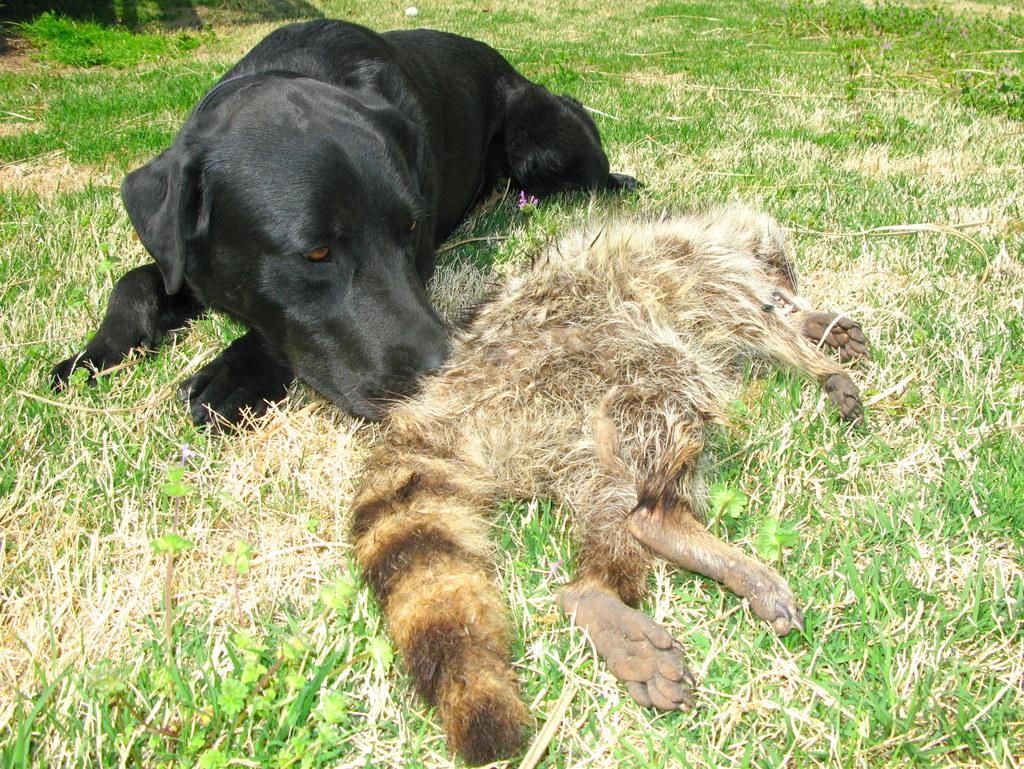What types of living organisms can be seen in the image? There are animals in the image. What are the animals doing in the image? The animals are lying on the ground. What is the surface on which the animals are lying? The ground is covered with grass. How many eggs can be seen in the image? There are no eggs present in the image. What type of grip do the animals have on the ground? The animals are lying on the ground, so they do not have a grip on the ground. 